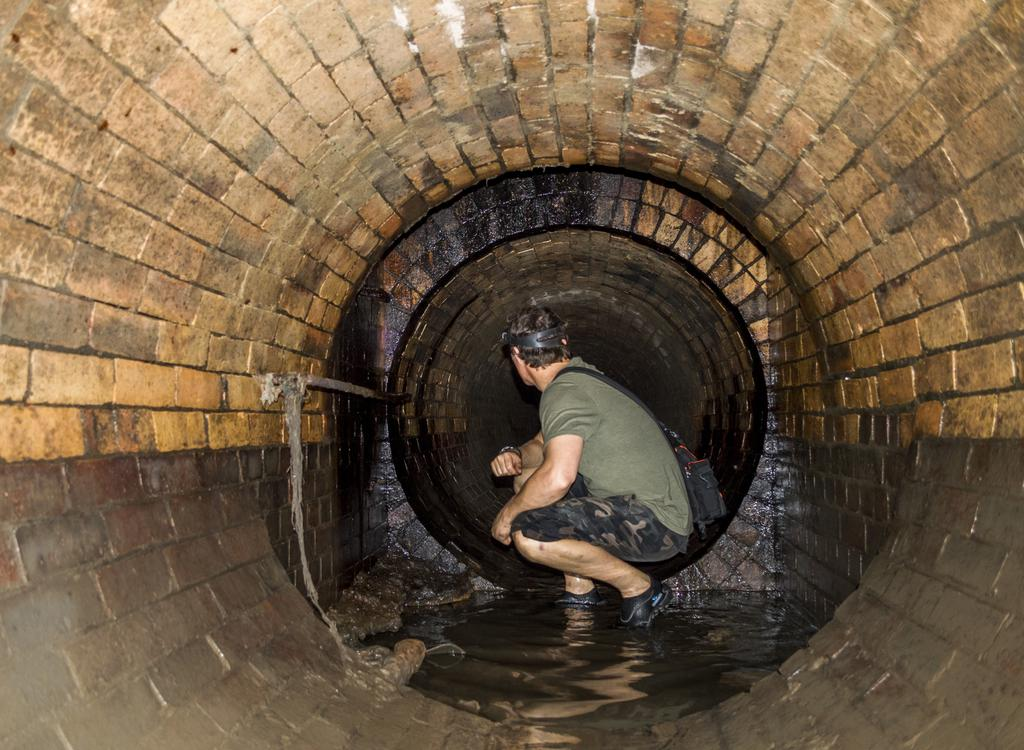Who is present in the image? There is a man in the image. What is the man wearing? The man is wearing a green dress. What is the man doing in the image? The man is sitting. What can be seen in the background of the image? There is a tunnel and water in the image. What type of line does the servant use to smoke in the image? There is no servant or smoking activity present in the image. 